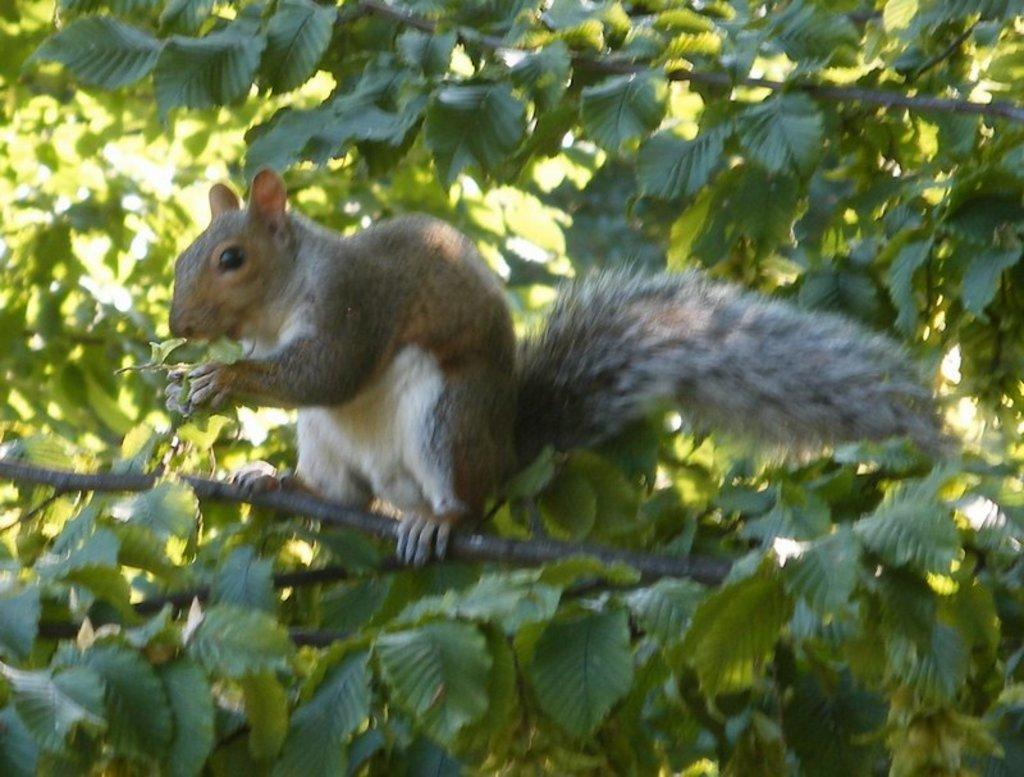What animal can be seen in the image? There is a squirrel in the image. Where is the squirrel located? The squirrel is on a branch of a tree. Can you describe the tree in the image? The tree is in the middle of the image. What else can be seen in the background of the image? There is at least one tree in the background of the image. What type of vein is visible on the squirrel's body in the image? There is no visible vein on the squirrel's body in the image. How many children are playing with the squirrel in the image? There are no children present in the image; it only features a squirrel on a tree branch. 